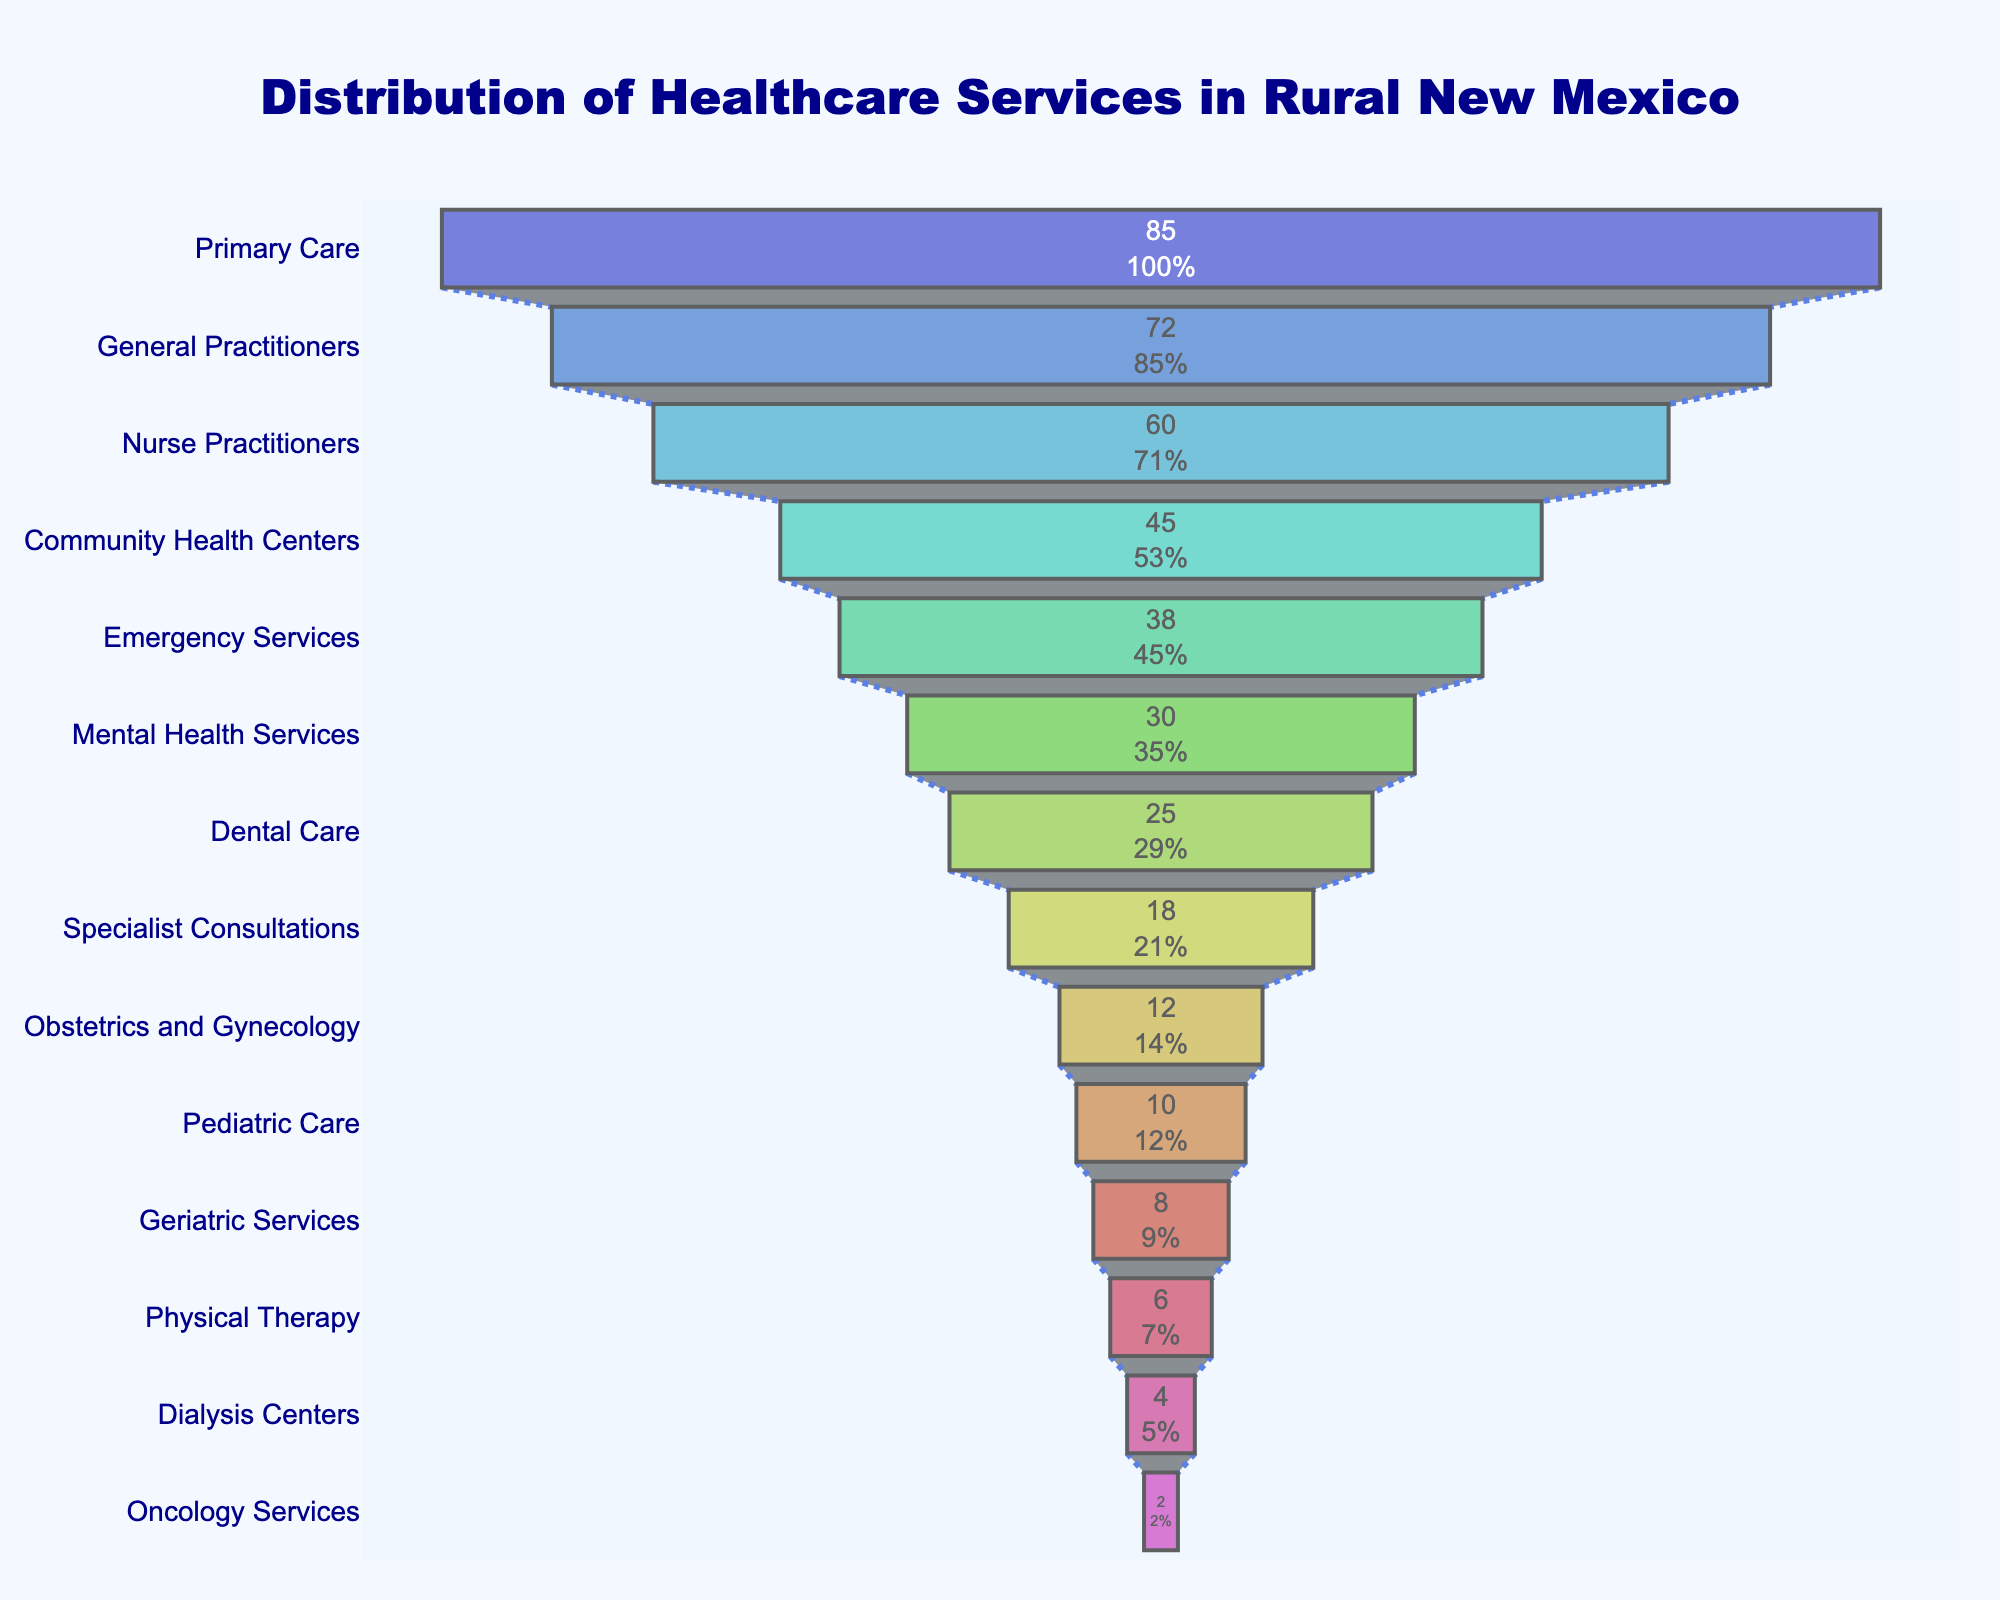What is the total number of healthcare services listed in the chart? To find the total number of healthcare services listed, count the number of bars in the funnel chart. There are 14 bars representing different healthcare services.
Answer: 14 Which healthcare service has the highest availability in rural New Mexico communities? Look at the bar which is the widest at the top of the funnel chart; it represents Primary Care with an availability of 85.
Answer: Primary Care How much higher is the availability of Primary Care compared to Pediatric Care? The availability of Primary Care is 85, and Pediatric Care is 10. Subtract 10 from 85 to find the difference. 85 - 10 = 75.
Answer: 75 Which service has the least availability, and what is its availability percentage? Look at the narrowest bar at the bottom of the funnel chart; it represents Oncology Services with an availability of 2. The percentage is shown on the bar itself.
Answer: Oncology Services, 2% How does the availability of Specialist Consultations compare to Mental Health Services? Locate both bars in the funnel chart. Specialist Consultations have an availability of 18, while Mental Health Services have an availability of 30. Medital Health Services have greater availability.
Answer: Mental Health Services have higher availability What is the combined availability of Emergency Services and Nurse Practitioners? Emergency Services have an availability of 38, and Nurse Practitioners have 60. Add these two values together: 38 + 60 = 98.
Answer: 98 Which service is more available: Geriatric Services or Physical Therapy? Compare both bars in the funnel chart. Geriatric Services have an availability of 8, and Physical Therapy has an availability of 6. Therefore, Geriatric Services are more available.
Answer: Geriatric Services What percentage of the initial total does Primary Care represent? The percentage is displayed on the bar for Primary Care in the funnel chart.
Answer: Check the chart for the exact percentage How many more services have an availability greater than 40 compared to those with less than 10? Count the services with availability greater than 40 (Primary Care, General Practitioners, Nurse Practitioners, Community Health Centers): 4. Now, count those with less than 10 (Pediatric Care, Geriatric Services, Physical Therapy, Dialysis Centers, Oncology Services): 5. Compare the two.
Answer: 4 services have availability greater than 40, 5 have less than 10 What is the difference in availability between Dental Care and Mental Health Services? Locate the bars for Mental Health Services (30) and Dental Care (25). Subtract the availability of Dental Care from Mental Health Services: 30 - 25 = 5.
Answer: 5 